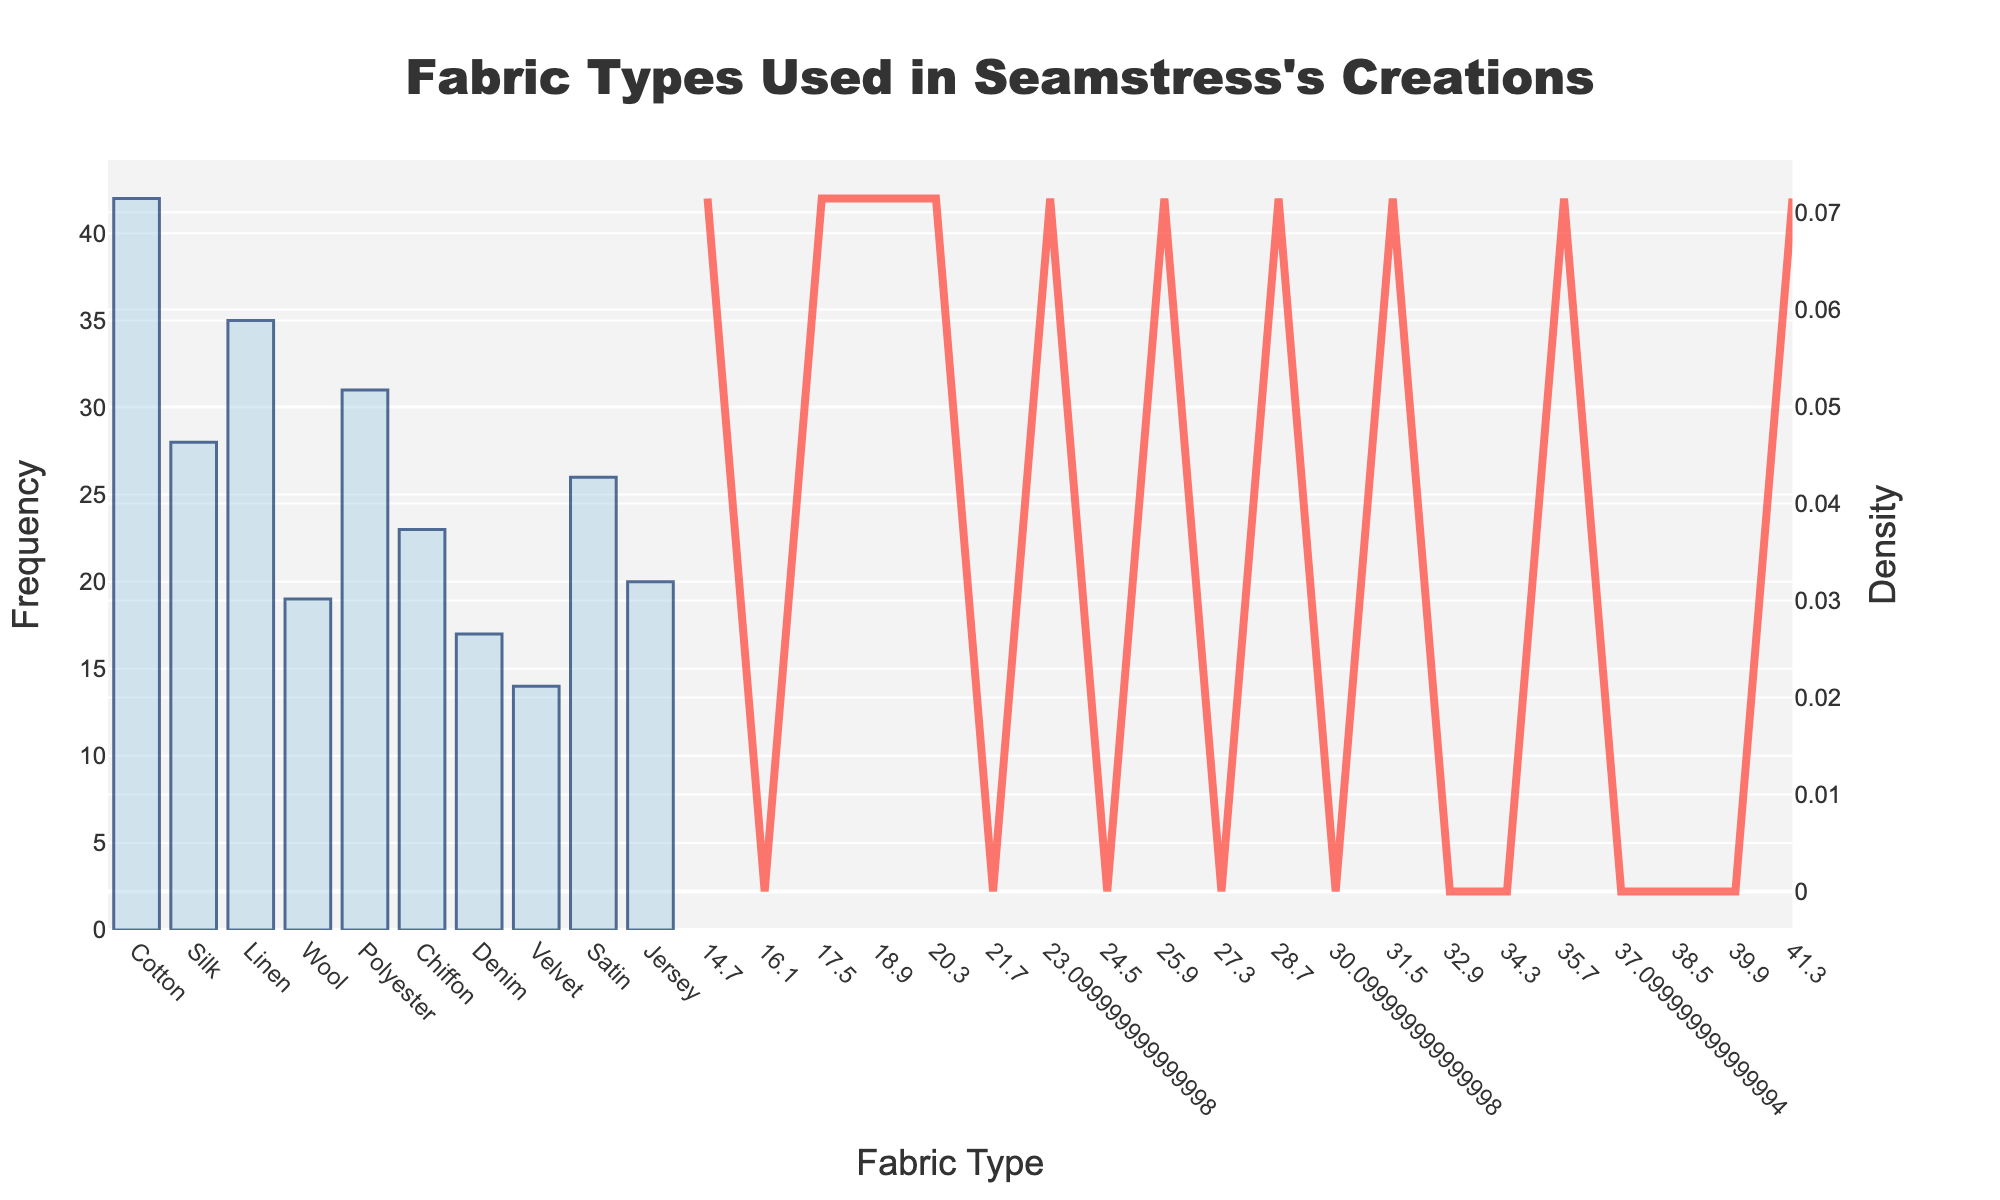What is the title of the figure? The title is located at the top of the figure. It provides a summary of what the figure is about.
Answer: Fabric Types Used in Seamstress's Creations What is the frequency of Cotton fabric? To find the frequency of Cotton, locate its bar on the x-axis and read the corresponding y-axis value.
Answer: 42 Which fabric type has the highest frequency? Compare the heights of all the bars to determine which one is the tallest. Cotton is the tallest.
Answer: Cotton Which fabric type has the lowest frequency? Compare the heights of all the bars to find the one that is the shortest. Velvet is the shortest.
Answer: Velvet What is the average frequency of Linen and Polyester fabrics? The frequencies of Linen and Polyester are 35 and 31 respectively. The average is calculated by (35 + 31) / 2.
Answer: 33 How many fabric types have more than 30 frequency? Identify and count the bars that extend above the y-axis value of 30. There are three: Cotton, Linen, and Polyester.
Answer: 3 What two fabric types have their frequencies closest to each other? Compare the y-axis values to find the smallest difference between pairs. Satin (26) and Silk (28) have a small difference of 2.
Answer: Satin and Silk Which fabric type has a higher frequency: Silk or Satin? Compare the heights of the bars for Silk and Satin. Silk's bar is higher.
Answer: Silk What's the total frequency of all fabric types combined? Sum the frequencies of all fabric types: 42 + 28 + 35 + 19 + 31 + 23 + 17 + 14 + 26 + 20. Total is 255.
Answer: 255 How does the height of the KDE curve change as the frequency increases? Follow the density curve on the secondary y-axis to see that it fluctuates but generally increases with higher frequency values and then stabilizes.
Answer: Increases then stabilizes 